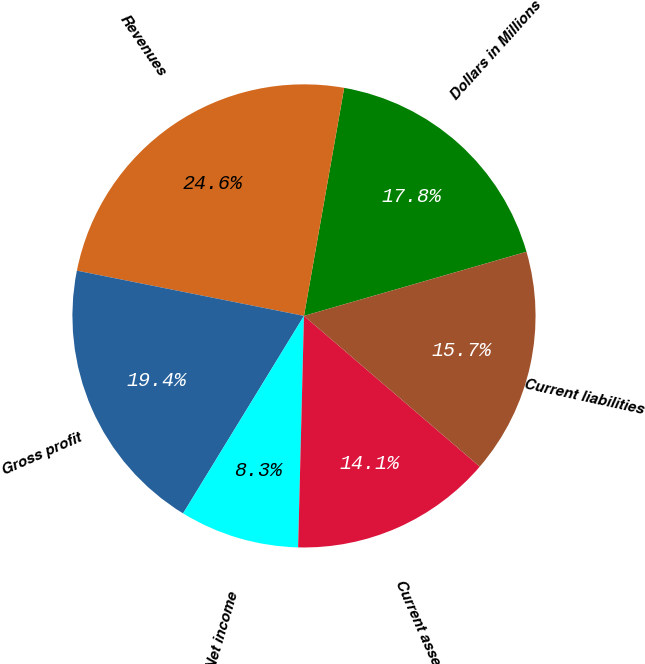Convert chart to OTSL. <chart><loc_0><loc_0><loc_500><loc_500><pie_chart><fcel>Dollars in Millions<fcel>Revenues<fcel>Gross profit<fcel>Net income<fcel>Current assets<fcel>Current liabilities<nl><fcel>17.76%<fcel>24.65%<fcel>19.39%<fcel>8.34%<fcel>14.12%<fcel>15.75%<nl></chart> 